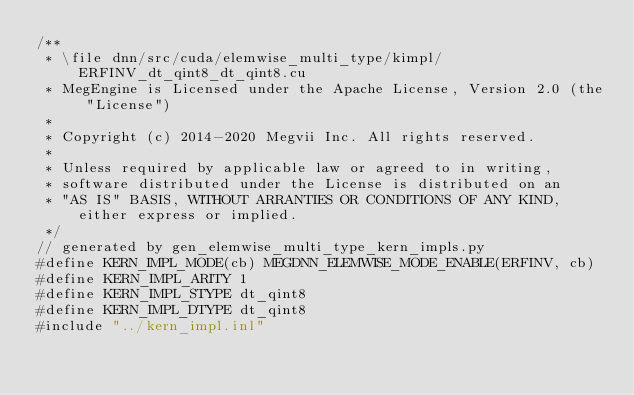Convert code to text. <code><loc_0><loc_0><loc_500><loc_500><_Cuda_>/**
 * \file dnn/src/cuda/elemwise_multi_type/kimpl/ERFINV_dt_qint8_dt_qint8.cu
 * MegEngine is Licensed under the Apache License, Version 2.0 (the "License")
 *
 * Copyright (c) 2014-2020 Megvii Inc. All rights reserved.
 *
 * Unless required by applicable law or agreed to in writing,
 * software distributed under the License is distributed on an
 * "AS IS" BASIS, WITHOUT ARRANTIES OR CONDITIONS OF ANY KIND, either express or implied.
 */
// generated by gen_elemwise_multi_type_kern_impls.py
#define KERN_IMPL_MODE(cb) MEGDNN_ELEMWISE_MODE_ENABLE(ERFINV, cb)
#define KERN_IMPL_ARITY 1
#define KERN_IMPL_STYPE dt_qint8
#define KERN_IMPL_DTYPE dt_qint8
#include "../kern_impl.inl"
</code> 